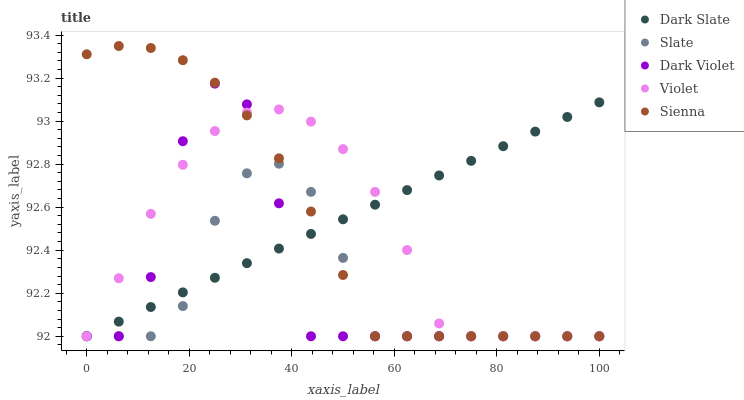Does Slate have the minimum area under the curve?
Answer yes or no. Yes. Does Dark Slate have the maximum area under the curve?
Answer yes or no. Yes. Does Dark Slate have the minimum area under the curve?
Answer yes or no. No. Does Slate have the maximum area under the curve?
Answer yes or no. No. Is Dark Slate the smoothest?
Answer yes or no. Yes. Is Dark Violet the roughest?
Answer yes or no. Yes. Is Slate the smoothest?
Answer yes or no. No. Is Slate the roughest?
Answer yes or no. No. Does Sienna have the lowest value?
Answer yes or no. Yes. Does Sienna have the highest value?
Answer yes or no. Yes. Does Dark Slate have the highest value?
Answer yes or no. No. Does Dark Slate intersect Slate?
Answer yes or no. Yes. Is Dark Slate less than Slate?
Answer yes or no. No. Is Dark Slate greater than Slate?
Answer yes or no. No. 